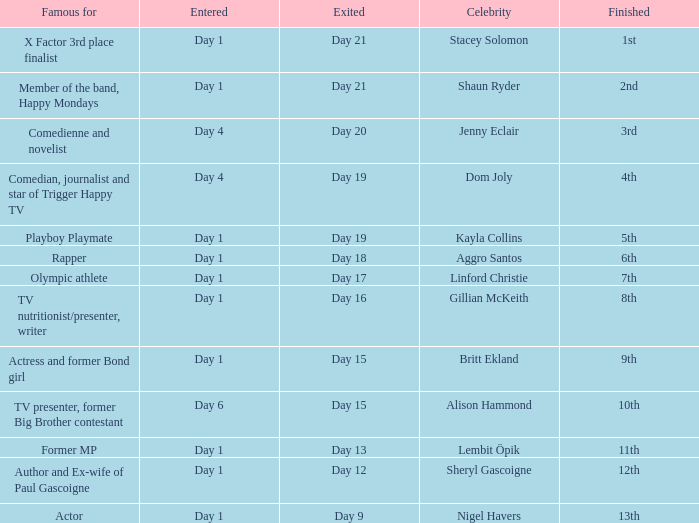Which celebrity was famous for being a rapper? Aggro Santos. 